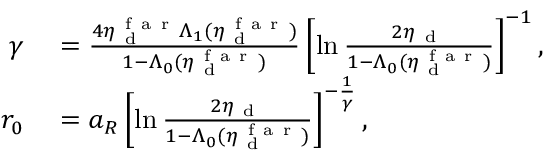Convert formula to latex. <formula><loc_0><loc_0><loc_500><loc_500>\begin{array} { r l } { \gamma } & = \frac { 4 \eta _ { d } ^ { f a r } \Lambda _ { 1 } ( \eta _ { d } ^ { f a r } ) } { 1 - \Lambda _ { 0 } ( \eta _ { d } ^ { f a r } ) } \left [ \ln \frac { 2 \eta _ { d } } { 1 - \Lambda _ { 0 } ( \eta _ { d } ^ { f a r } ) } \right ] ^ { - 1 } , } \\ { r _ { 0 } } & = a _ { R } \left [ \ln \frac { 2 \eta _ { d } } { 1 - \Lambda _ { 0 } ( \eta _ { d } ^ { f a r } ) } \right ] ^ { - \frac { 1 } { \gamma } } , } \end{array}</formula> 